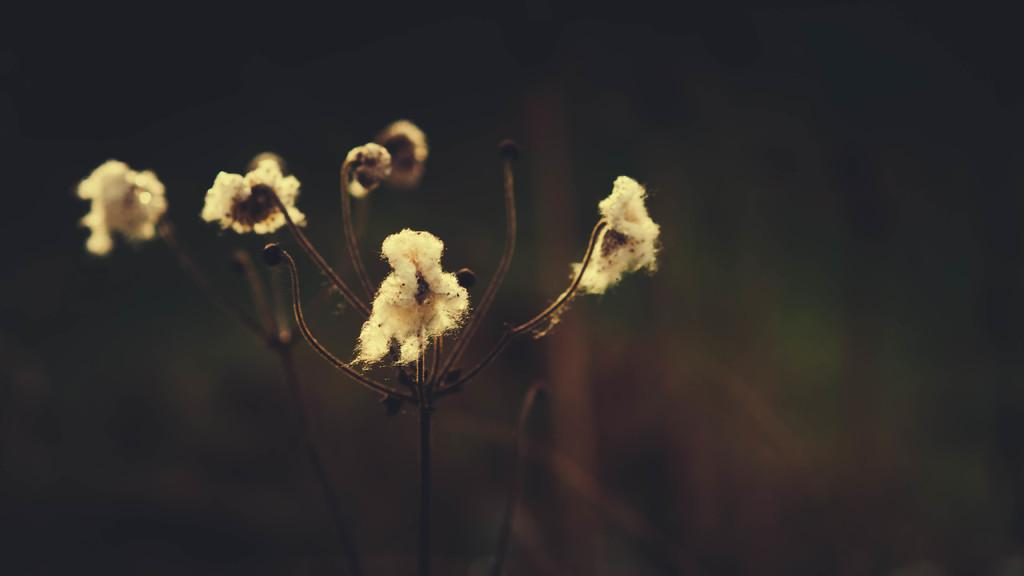What type of plant is in the foreground of the image? There is a cotton plant in the foreground of the image. Can you describe the background of the image? The background of the image is blurred. How much jelly is being produced by the cotton plant in the image? There is no jelly production associated with cotton plants; they produce cotton fibers. 